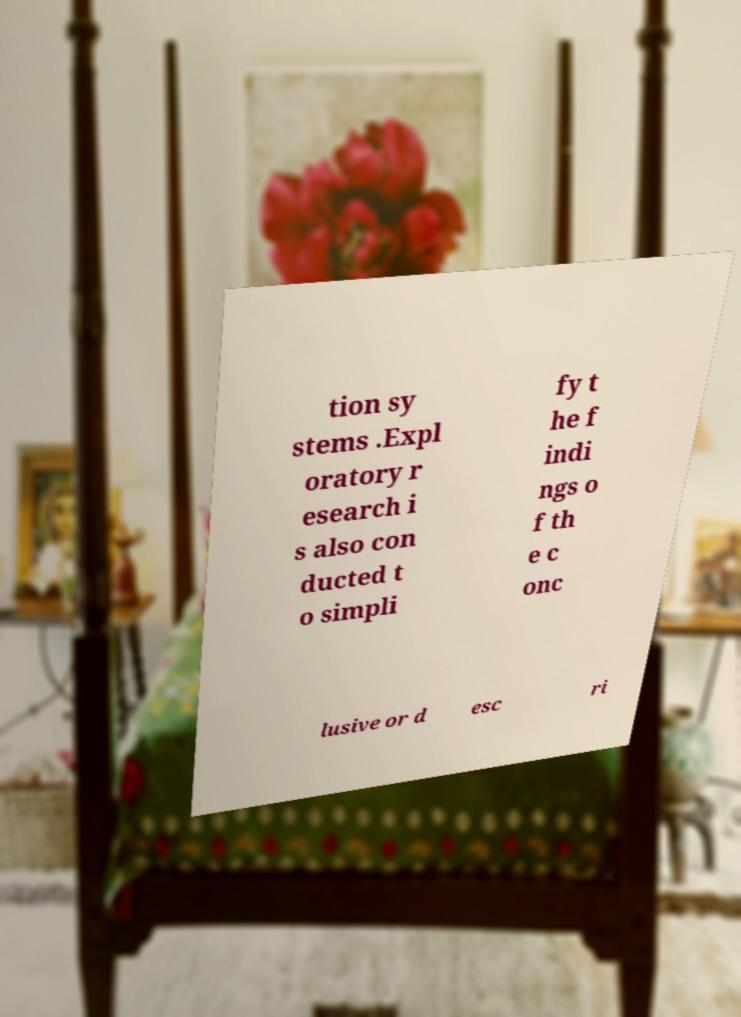For documentation purposes, I need the text within this image transcribed. Could you provide that? tion sy stems .Expl oratory r esearch i s also con ducted t o simpli fy t he f indi ngs o f th e c onc lusive or d esc ri 